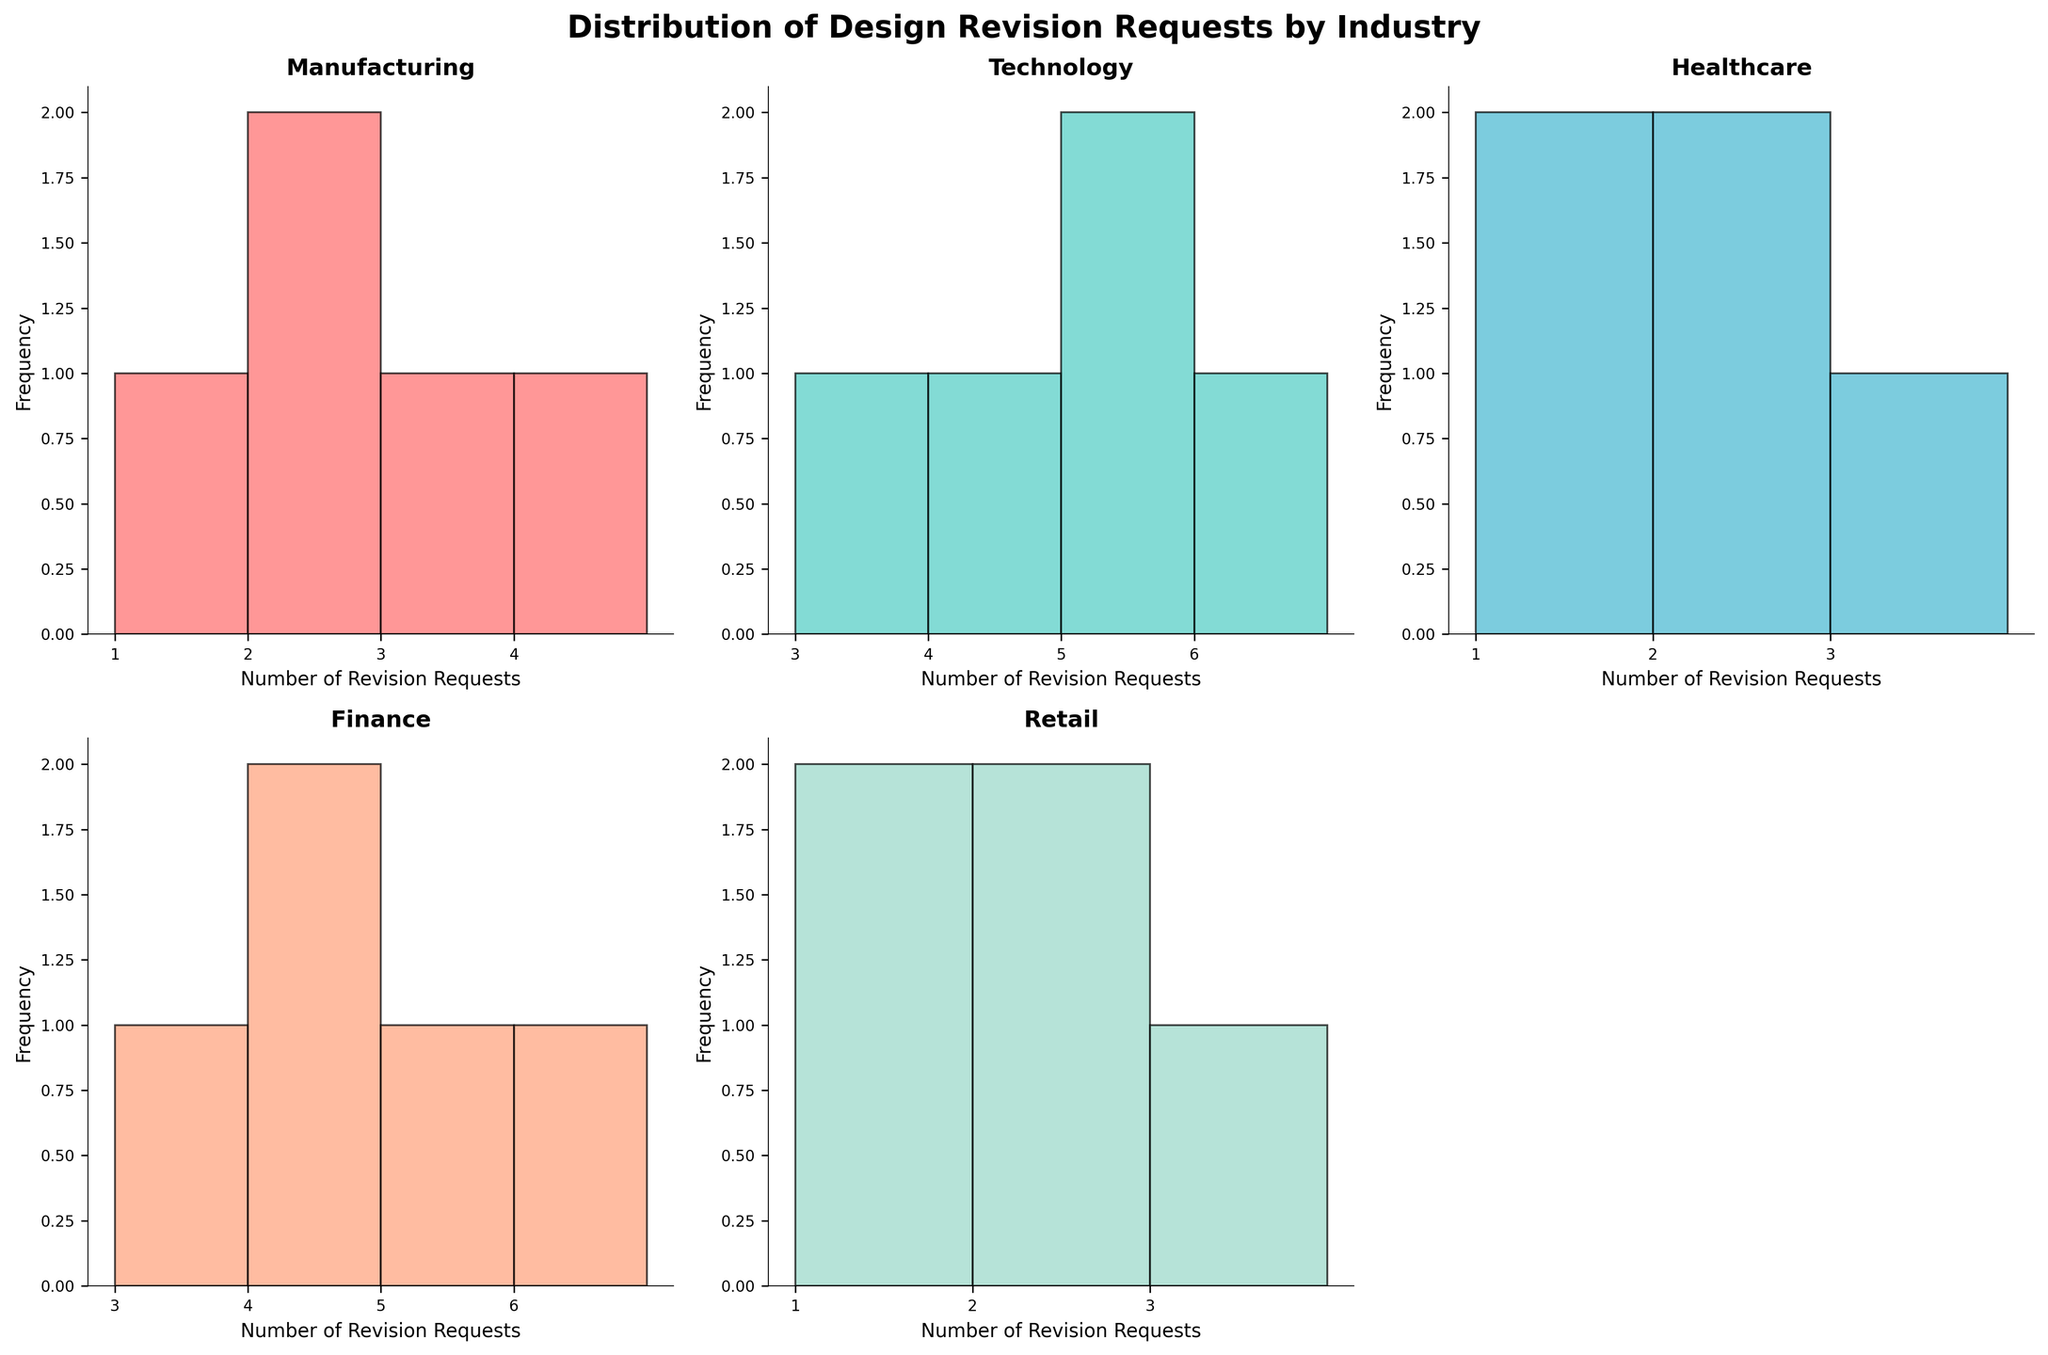how many bins are used for the Manufacturing industry histogram? The Manufacturing industry histogram shows bins ranging from 1 to 4, inclusive. Each integer between 1 and 4 is a bin, making a total of 4 bins.
Answer: 4 Which industry has the highest frequency of revision requests at the number 3? By inspecting the histograms, we see that the Finance industry has the highest frequency for 3 revision requests with a peak reaching 2.
Answer: Finance What is the total number of revision requests for the Healthcare industry? Summing up the number of revision requests for Healthcare from the histogram, the values are 1, 2, 1, 3, 2, which totals up to 9.
Answer: 9 Which industry shows the most varied distribution of revision requests? The Technology industry’s histogram spans from 3 to 6 revision requests, suggesting a more spread-out distribution compared to others with smaller ranges.
Answer: Technology What is the average number of revision requests in the Retail industry? Adding the Retail industry’s revision requests (2, 1, 3, 2, 1) gives 9. Dividing by the number of requests (5) results in an average of 1.8.
Answer: 1.8 How many industries have their histograms peaking at 2 revision requests? Both the Retail and Manufacturing industries display a peak at 2 revision requests when looking at their respective histograms.
Answer: 2 Which industry has the most concentrated number of revision requests around a single value? The Healthcare industry shows a clear concentration around the values 1 and 2, with more requests clustered around these values compared to other industries.
Answer: Healthcare Is there any industry where the number of revision requests never exceed 4? Both the Manufacturing and Retail industries have histograms where the revision requests do not exceed 4.
Answer: Yes How does the average revision requests in the Finance industry compare to Manufacturing? For Finance, averaging (4+5+3+6+4) equals 22/5 = 4.4. For Manufacturing, averaging (2+3+1+4+2) equals 12/5 = 2.4. Finance's average of revision requests is higher.
Answer: Finance has a higher average 